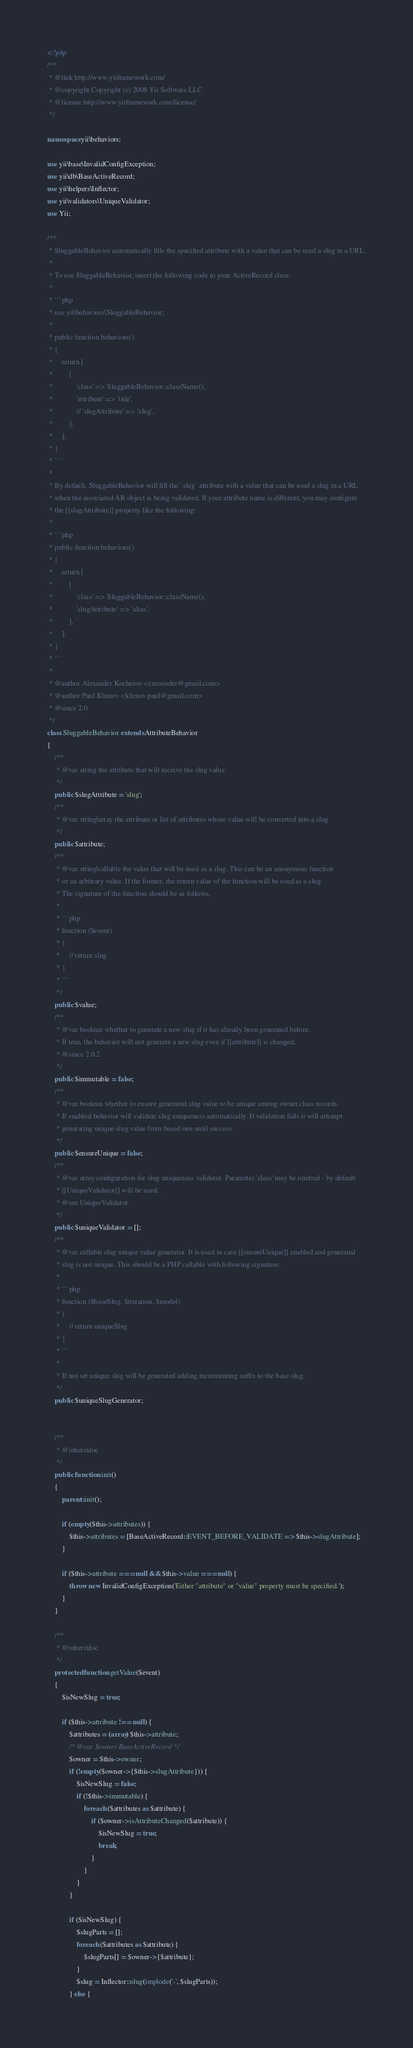Convert code to text. <code><loc_0><loc_0><loc_500><loc_500><_PHP_><?php
/**
 * @link http://www.yiiframework.com/
 * @copyright Copyright (c) 2008 Yii Software LLC
 * @license http://www.yiiframework.com/license/
 */

namespace yii\behaviors;

use yii\base\InvalidConfigException;
use yii\db\BaseActiveRecord;
use yii\helpers\Inflector;
use yii\validators\UniqueValidator;
use Yii;

/**
 * SluggableBehavior automatically fills the specified attribute with a value that can be used a slug in a URL.
 *
 * To use SluggableBehavior, insert the following code to your ActiveRecord class:
 *
 * ```php
 * use yii\behaviors\SluggableBehavior;
 *
 * public function behaviors()
 * {
 *     return [
 *         [
 *             'class' => SluggableBehavior::className(),
 *             'attribute' => 'title',
 *             // 'slugAttribute' => 'slug',
 *         ],
 *     ];
 * }
 * ```
 *
 * By default, SluggableBehavior will fill the `slug` attribute with a value that can be used a slug in a URL
 * when the associated AR object is being validated. If your attribute name is different, you may configure
 * the [[slugAttribute]] property like the following:
 *
 * ```php
 * public function behaviors()
 * {
 *     return [
 *         [
 *             'class' => SluggableBehavior::className(),
 *             'slugAttribute' => 'alias',
 *         ],
 *     ];
 * }
 * ```
 *
 * @author Alexander Kochetov <creocoder@gmail.com>
 * @author Paul Klimov <klimov.paul@gmail.com>
 * @since 2.0
 */
class SluggableBehavior extends AttributeBehavior
{
    /**
     * @var string the attribute that will receive the slug value
     */
    public $slugAttribute = 'slug';
    /**
     * @var string|array the attribute or list of attributes whose value will be converted into a slug
     */
    public $attribute;
    /**
     * @var string|callable the value that will be used as a slug. This can be an anonymous function
     * or an arbitrary value. If the former, the return value of the function will be used as a slug.
     * The signature of the function should be as follows,
     *
     * ```php
     * function ($event)
     * {
     *     // return slug
     * }
     * ```
     */
    public $value;
    /**
     * @var boolean whether to generate a new slug if it has already been generated before.
     * If true, the behavior will not generate a new slug even if [[attribute]] is changed.
     * @since 2.0.2
     */
    public $immutable = false;
    /**
     * @var boolean whether to ensure generated slug value to be unique among owner class records.
     * If enabled behavior will validate slug uniqueness automatically. If validation fails it will attempt
     * generating unique slug value from based one until success.
     */
    public $ensureUnique = false;
    /**
     * @var array configuration for slug uniqueness validator. Parameter 'class' may be omitted - by default
     * [[UniqueValidator]] will be used.
     * @see UniqueValidator
     */
    public $uniqueValidator = [];
    /**
     * @var callable slug unique value generator. It is used in case [[ensureUnique]] enabled and generated
     * slug is not unique. This should be a PHP callable with following signature:
     *
     * ```php
     * function ($baseSlug, $iteration, $model)
     * {
     *     // return uniqueSlug
     * }
     * ```
     *
     * If not set unique slug will be generated adding incrementing suffix to the base slug.
     */
    public $uniqueSlugGenerator;


    /**
     * @inheritdoc
     */
    public function init()
    {
        parent::init();

        if (empty($this->attributes)) {
            $this->attributes = [BaseActiveRecord::EVENT_BEFORE_VALIDATE => $this->slugAttribute];
        }

        if ($this->attribute === null && $this->value === null) {
            throw new InvalidConfigException('Either "attribute" or "value" property must be specified.');
        }
    }

    /**
     * @inheritdoc
     */
    protected function getValue($event)
    {
        $isNewSlug = true;

        if ($this->attribute !== null) {
            $attributes = (array) $this->attribute;
            /* @var $owner BaseActiveRecord */
            $owner = $this->owner;
            if (!empty($owner->{$this->slugAttribute})) {
                $isNewSlug = false;
                if (!$this->immutable) {
                    foreach ($attributes as $attribute) {
                        if ($owner->isAttributeChanged($attribute)) {
                            $isNewSlug = true;
                            break;
                        }
                    }
                }
            }

            if ($isNewSlug) {
                $slugParts = [];
                foreach ($attributes as $attribute) {
                    $slugParts[] = $owner->{$attribute};
                }
                $slug = Inflector::slug(implode('-', $slugParts));
            } else {</code> 